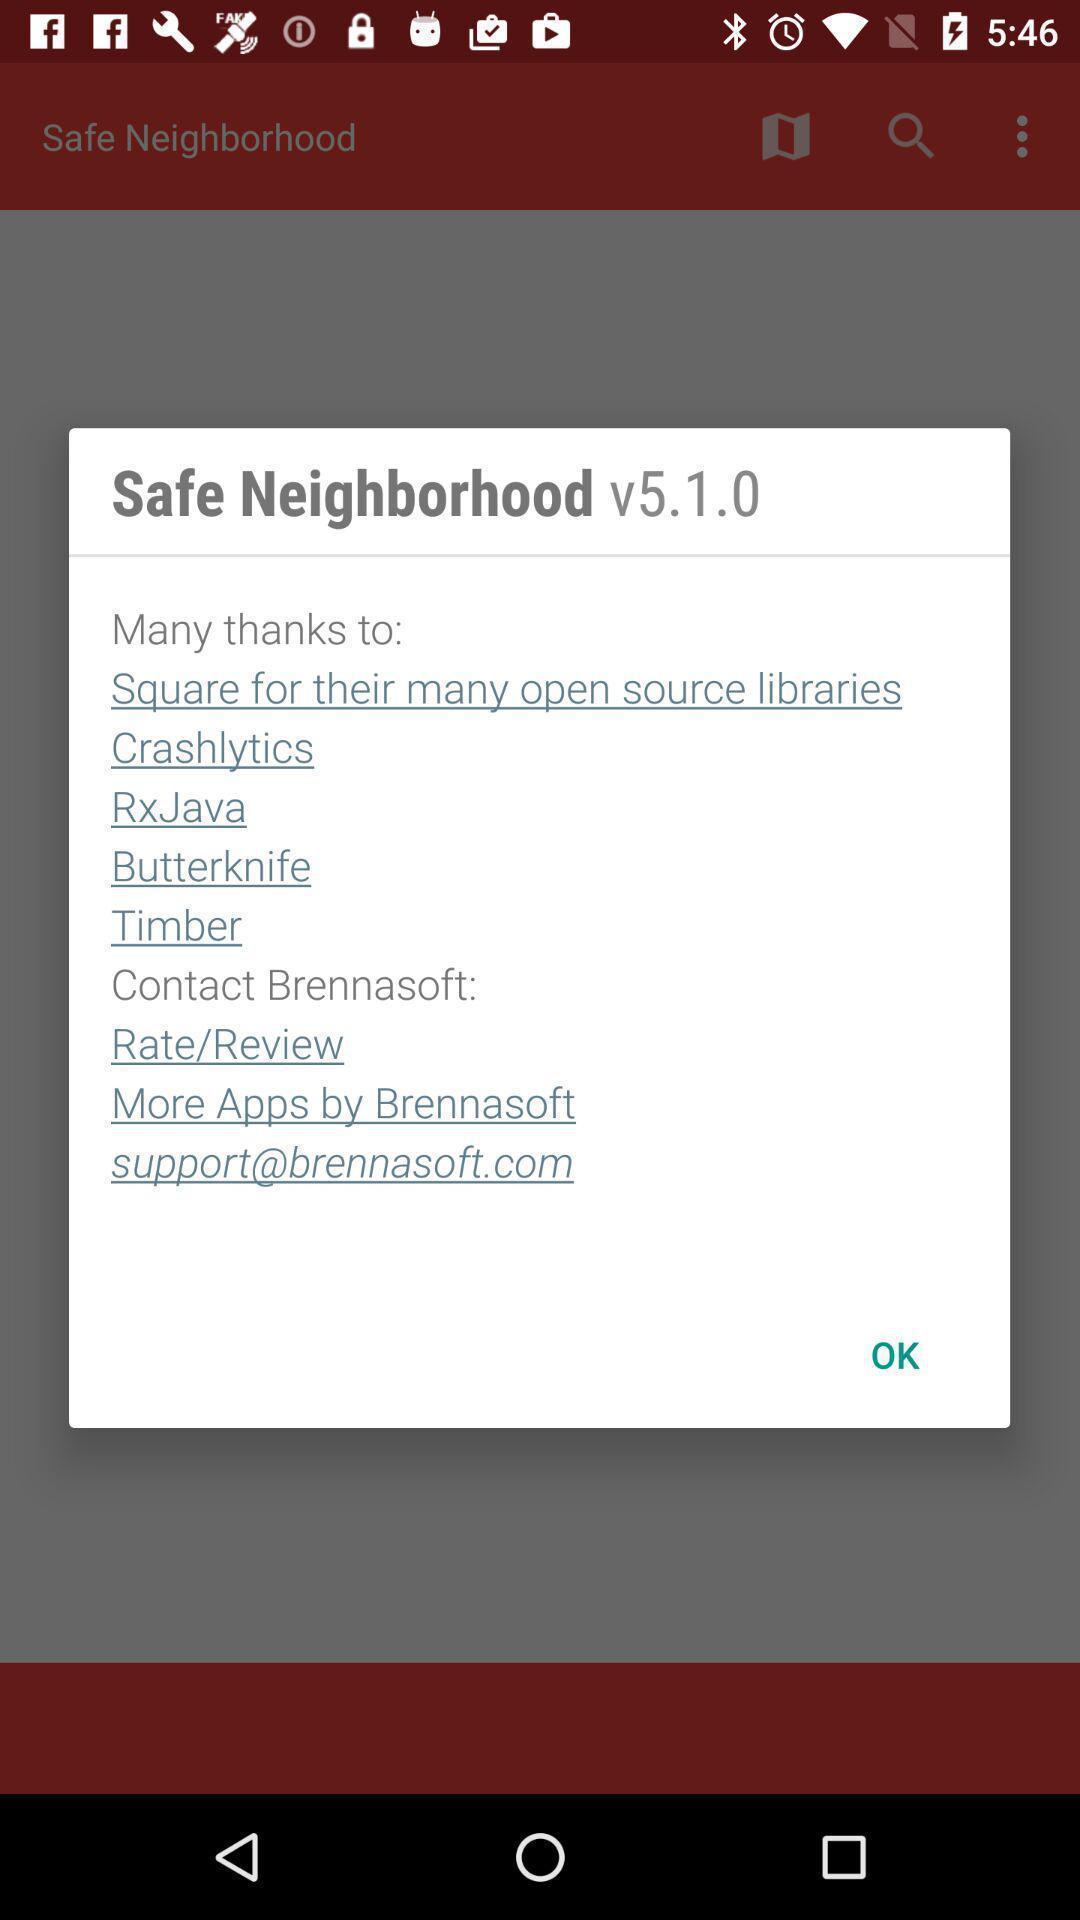Describe the key features of this screenshot. Pop-up window showing app version and contacting details. 